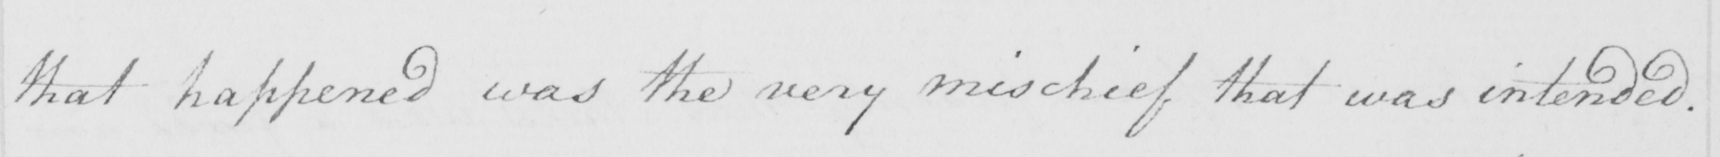What does this handwritten line say? that happened was the very mischief that was intended . 